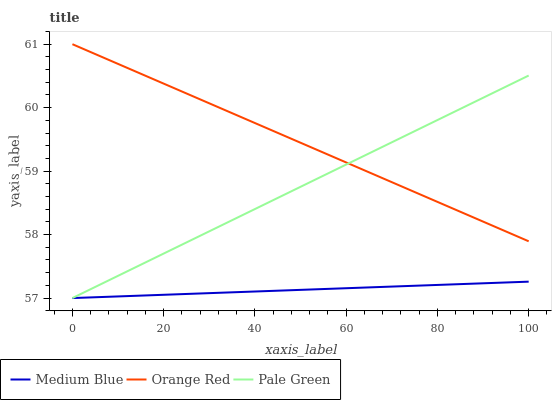Does Medium Blue have the minimum area under the curve?
Answer yes or no. Yes. Does Orange Red have the maximum area under the curve?
Answer yes or no. Yes. Does Orange Red have the minimum area under the curve?
Answer yes or no. No. Does Medium Blue have the maximum area under the curve?
Answer yes or no. No. Is Orange Red the smoothest?
Answer yes or no. Yes. Is Pale Green the roughest?
Answer yes or no. Yes. Is Medium Blue the smoothest?
Answer yes or no. No. Is Medium Blue the roughest?
Answer yes or no. No. Does Pale Green have the lowest value?
Answer yes or no. Yes. Does Orange Red have the lowest value?
Answer yes or no. No. Does Orange Red have the highest value?
Answer yes or no. Yes. Does Medium Blue have the highest value?
Answer yes or no. No. Is Medium Blue less than Orange Red?
Answer yes or no. Yes. Is Orange Red greater than Medium Blue?
Answer yes or no. Yes. Does Pale Green intersect Medium Blue?
Answer yes or no. Yes. Is Pale Green less than Medium Blue?
Answer yes or no. No. Is Pale Green greater than Medium Blue?
Answer yes or no. No. Does Medium Blue intersect Orange Red?
Answer yes or no. No. 